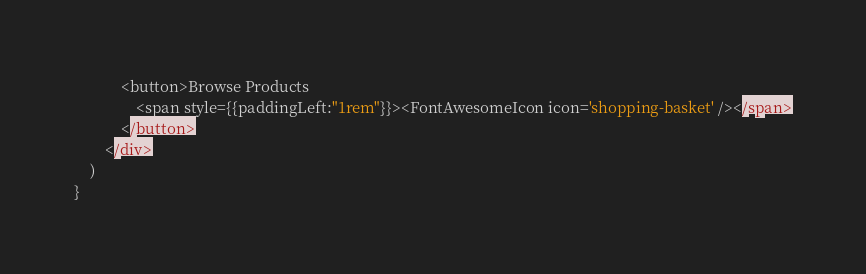Convert code to text. <code><loc_0><loc_0><loc_500><loc_500><_JavaScript_>            <button>Browse Products 
                <span style={{paddingLeft:"1rem"}}><FontAwesomeIcon icon='shopping-basket' /></span>
            </button>
        </div>
    )
}
</code> 